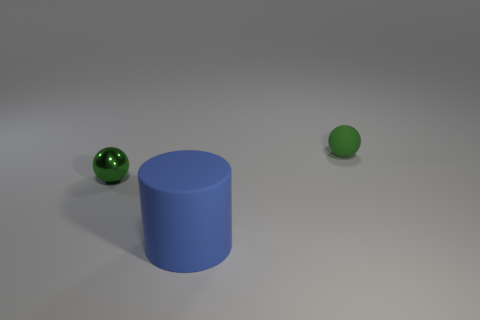There is a large blue object that is in front of the tiny green matte sphere; what shape is it?
Your answer should be very brief. Cylinder. Is there a small rubber thing to the left of the ball right of the big matte thing?
Provide a short and direct response. No. What number of cyan things have the same material as the cylinder?
Provide a succinct answer. 0. What is the size of the thing that is on the right side of the big blue rubber cylinder in front of the small green ball that is on the left side of the cylinder?
Provide a short and direct response. Small. There is a big rubber object; what number of blue cylinders are in front of it?
Your answer should be compact. 0. Are there more blue cylinders than tiny red cylinders?
Your answer should be very brief. Yes. There is a matte object that is the same color as the small metal sphere; what is its size?
Ensure brevity in your answer.  Small. There is a thing that is on the left side of the green matte sphere and behind the big blue thing; how big is it?
Offer a terse response. Small. What is the material of the tiny ball that is in front of the green thing that is on the right side of the small green thing that is left of the tiny rubber object?
Provide a succinct answer. Metal. There is another small ball that is the same color as the rubber sphere; what is its material?
Make the answer very short. Metal. 